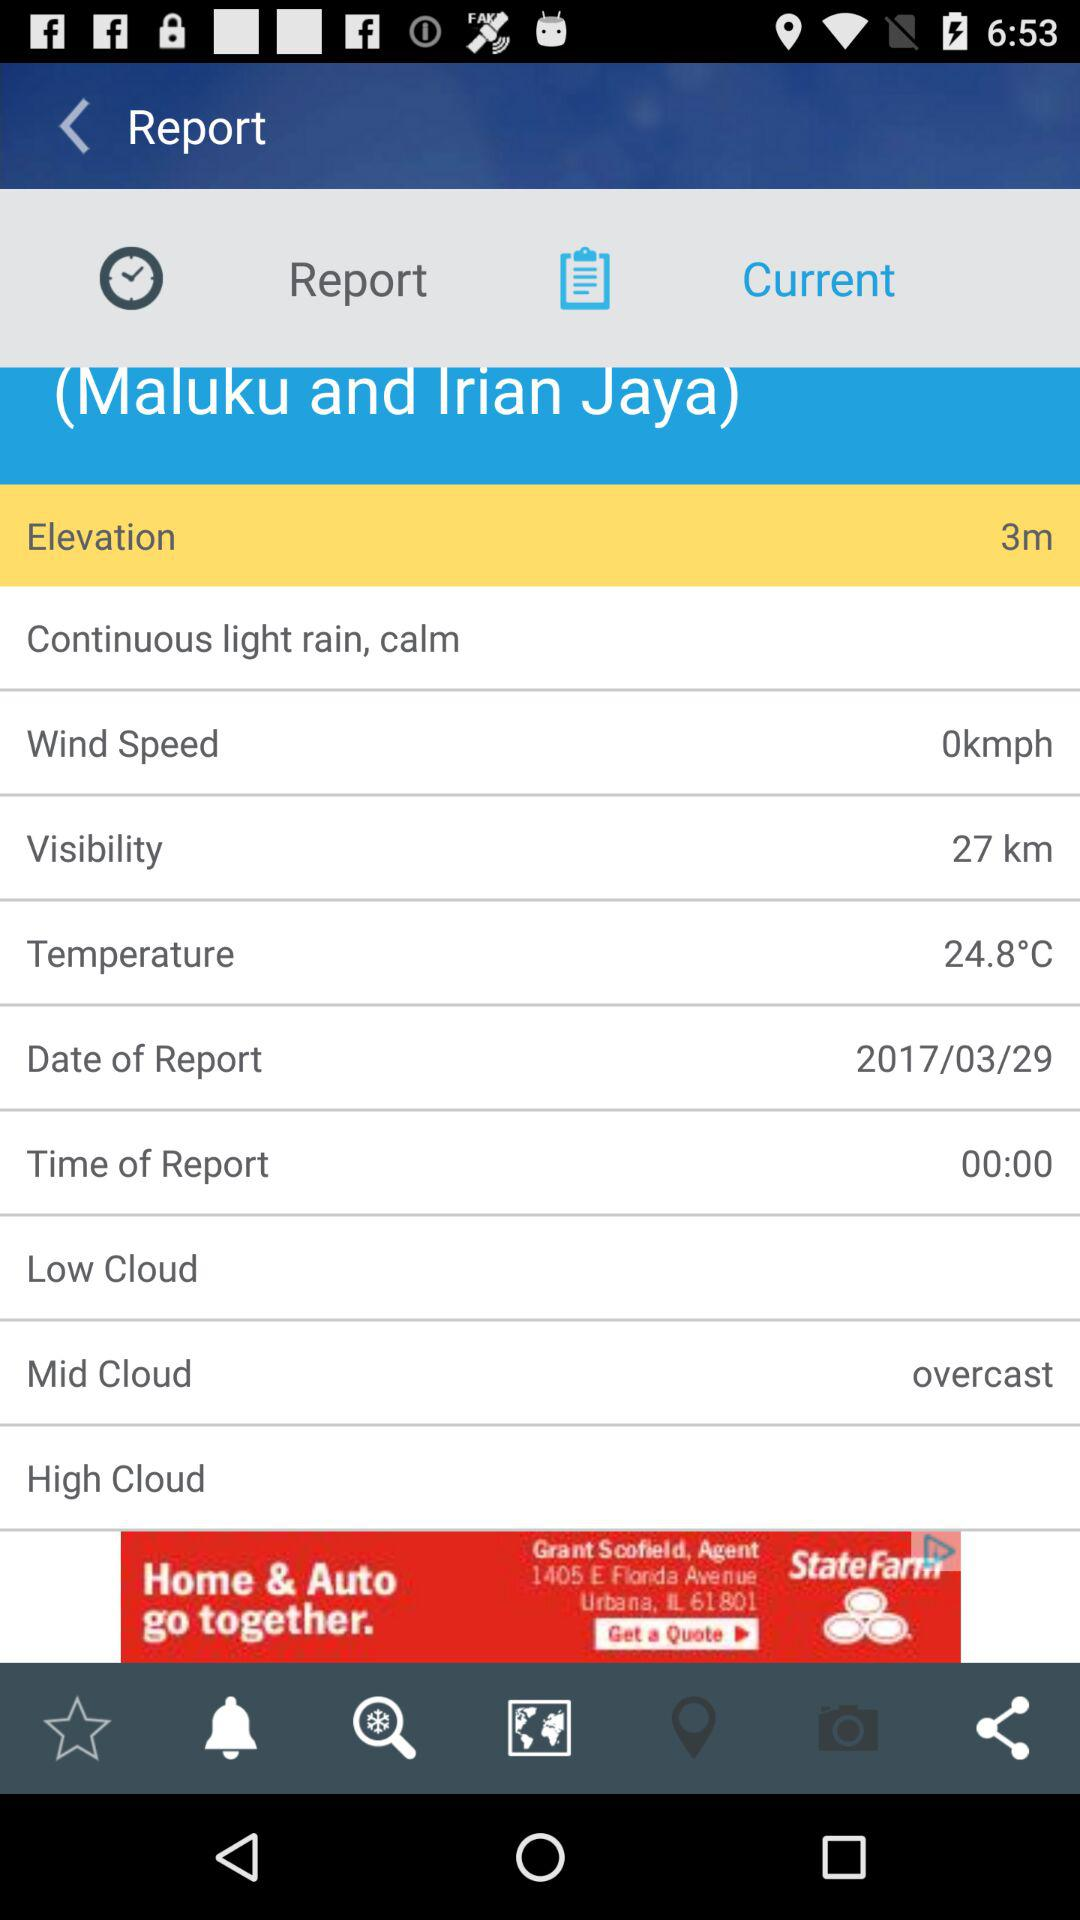What is the date of the report? The date of the report is March 29, 2017. 